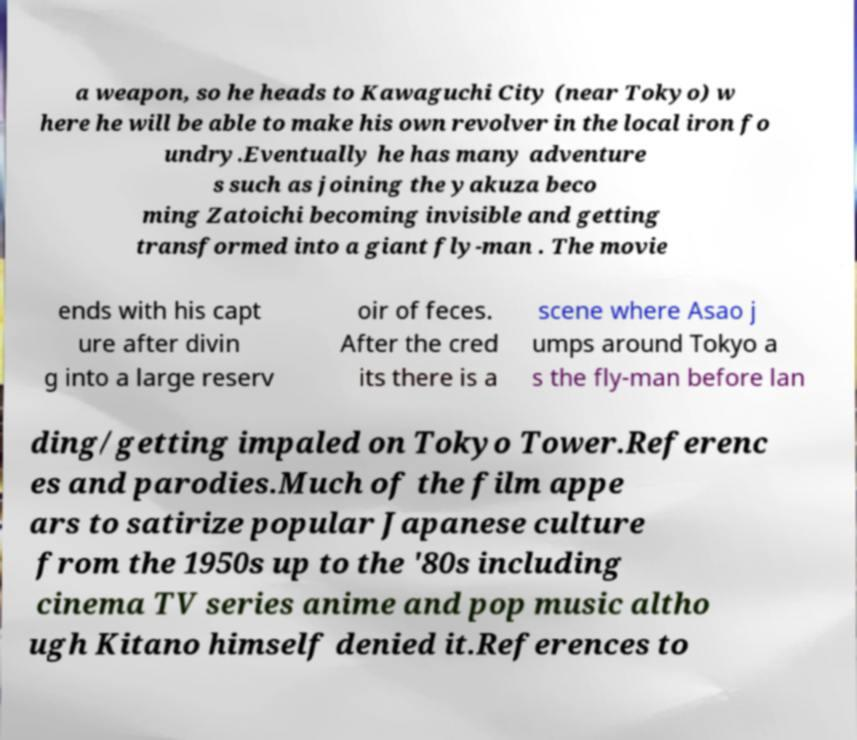For documentation purposes, I need the text within this image transcribed. Could you provide that? a weapon, so he heads to Kawaguchi City (near Tokyo) w here he will be able to make his own revolver in the local iron fo undry.Eventually he has many adventure s such as joining the yakuza beco ming Zatoichi becoming invisible and getting transformed into a giant fly-man . The movie ends with his capt ure after divin g into a large reserv oir of feces. After the cred its there is a scene where Asao j umps around Tokyo a s the fly-man before lan ding/getting impaled on Tokyo Tower.Referenc es and parodies.Much of the film appe ars to satirize popular Japanese culture from the 1950s up to the '80s including cinema TV series anime and pop music altho ugh Kitano himself denied it.References to 